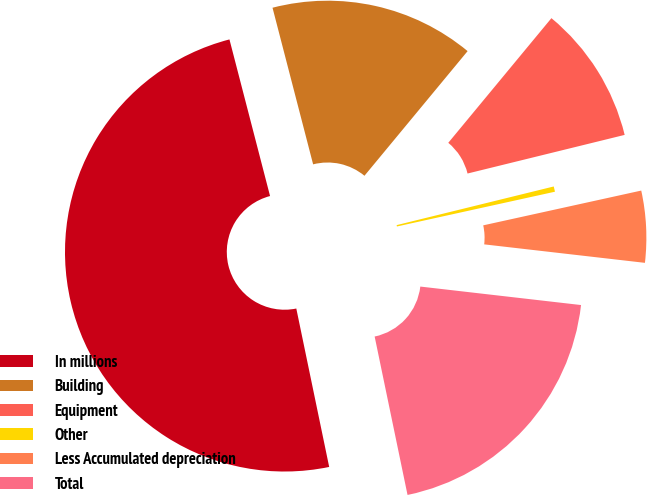Convert chart. <chart><loc_0><loc_0><loc_500><loc_500><pie_chart><fcel>In millions<fcel>Building<fcel>Equipment<fcel>Other<fcel>Less Accumulated depreciation<fcel>Total<nl><fcel>49.22%<fcel>15.04%<fcel>10.16%<fcel>0.39%<fcel>5.27%<fcel>19.92%<nl></chart> 